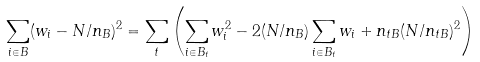Convert formula to latex. <formula><loc_0><loc_0><loc_500><loc_500>\sum _ { i \in B } ( w _ { i } - N / n _ { B } ) ^ { 2 } = \sum _ { t } \left ( \sum _ { i \in B _ { t } } w _ { i } ^ { 2 } - 2 ( N / n _ { B } ) \sum _ { i \in B _ { t } } w _ { i } + n _ { t B } ( N / n _ { t B } ) ^ { 2 } \right )</formula> 